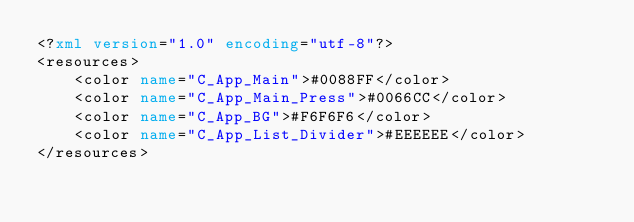<code> <loc_0><loc_0><loc_500><loc_500><_XML_><?xml version="1.0" encoding="utf-8"?>
<resources>
    <color name="C_App_Main">#0088FF</color>
    <color name="C_App_Main_Press">#0066CC</color>
    <color name="C_App_BG">#F6F6F6</color>
    <color name="C_App_List_Divider">#EEEEEE</color>
</resources>
</code> 